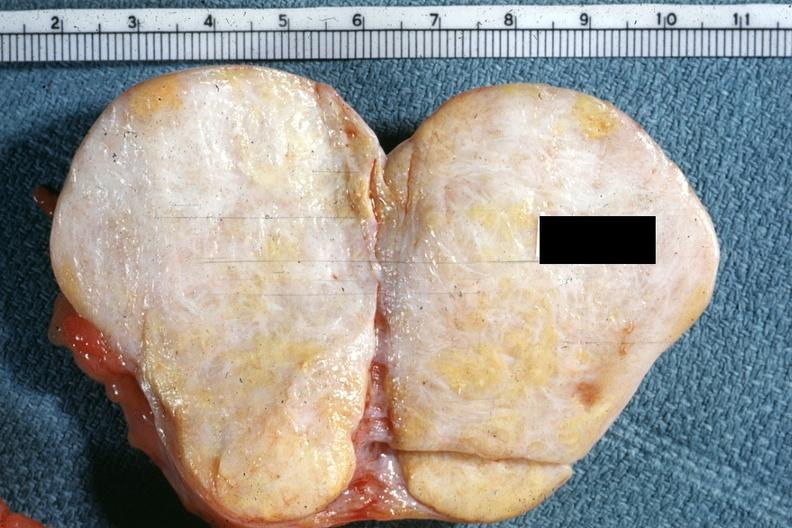how is this typical thecoma with yellow foci quite?
Answer the question using a single word or phrase. Obvious 